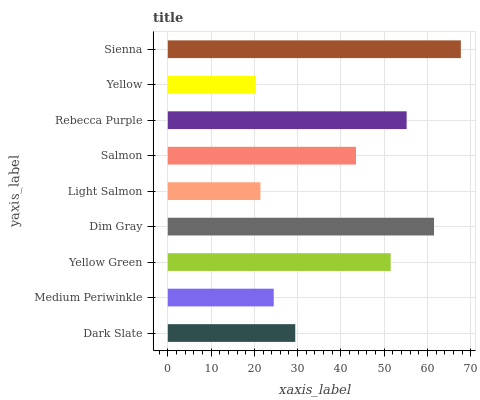Is Yellow the minimum?
Answer yes or no. Yes. Is Sienna the maximum?
Answer yes or no. Yes. Is Medium Periwinkle the minimum?
Answer yes or no. No. Is Medium Periwinkle the maximum?
Answer yes or no. No. Is Dark Slate greater than Medium Periwinkle?
Answer yes or no. Yes. Is Medium Periwinkle less than Dark Slate?
Answer yes or no. Yes. Is Medium Periwinkle greater than Dark Slate?
Answer yes or no. No. Is Dark Slate less than Medium Periwinkle?
Answer yes or no. No. Is Salmon the high median?
Answer yes or no. Yes. Is Salmon the low median?
Answer yes or no. Yes. Is Yellow Green the high median?
Answer yes or no. No. Is Dim Gray the low median?
Answer yes or no. No. 